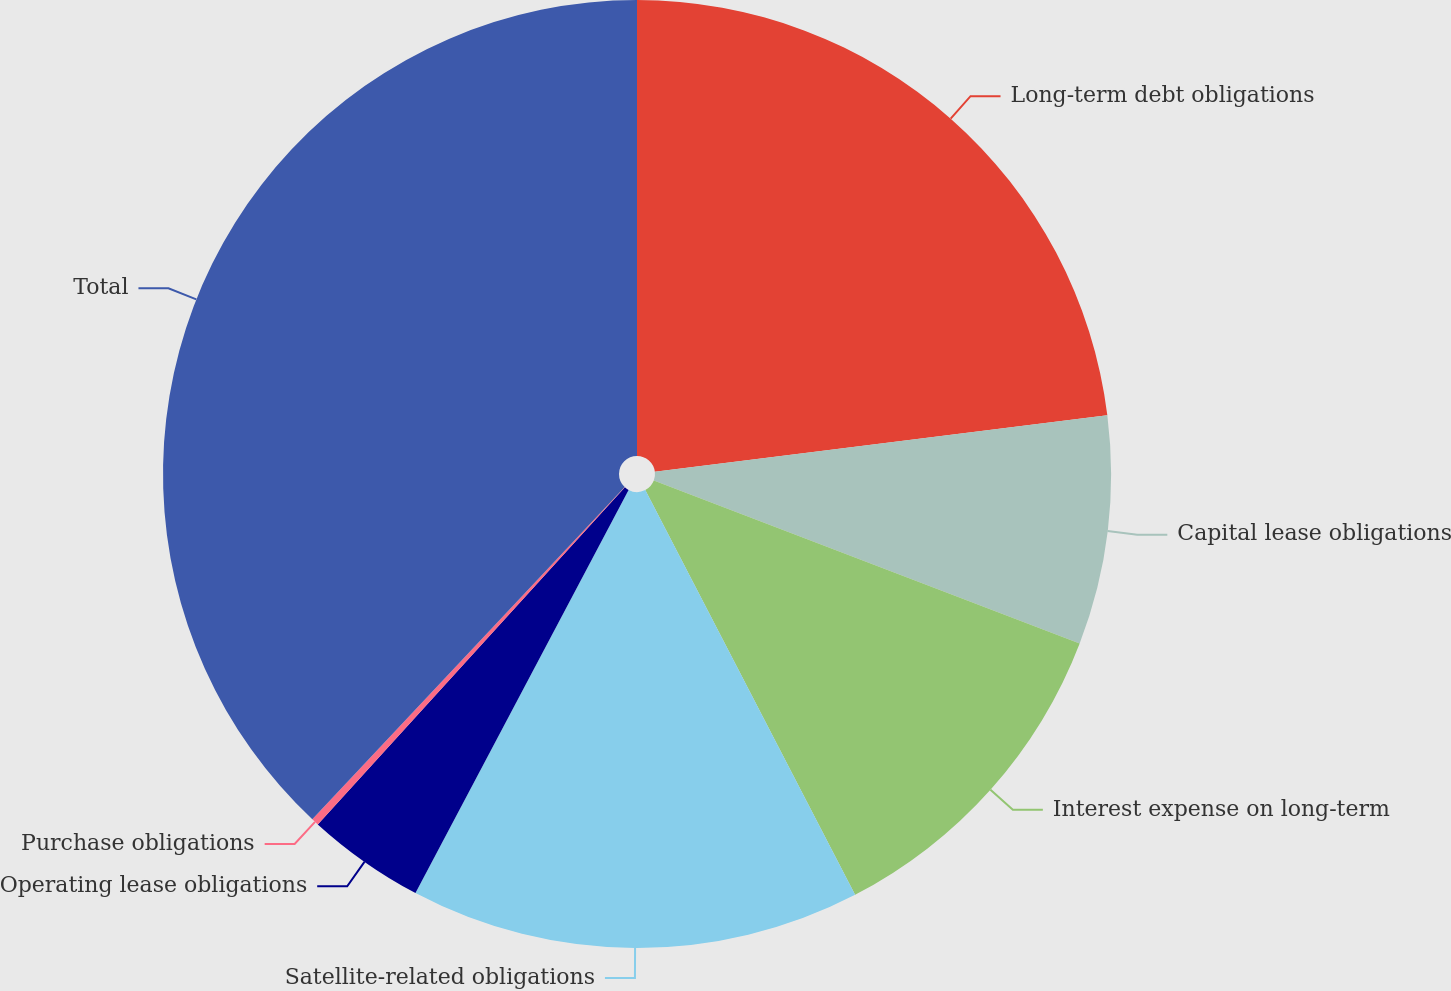Convert chart to OTSL. <chart><loc_0><loc_0><loc_500><loc_500><pie_chart><fcel>Long-term debt obligations<fcel>Capital lease obligations<fcel>Interest expense on long-term<fcel>Satellite-related obligations<fcel>Operating lease obligations<fcel>Purchase obligations<fcel>Total<nl><fcel>23.02%<fcel>7.8%<fcel>11.57%<fcel>15.35%<fcel>4.02%<fcel>0.25%<fcel>37.99%<nl></chart> 